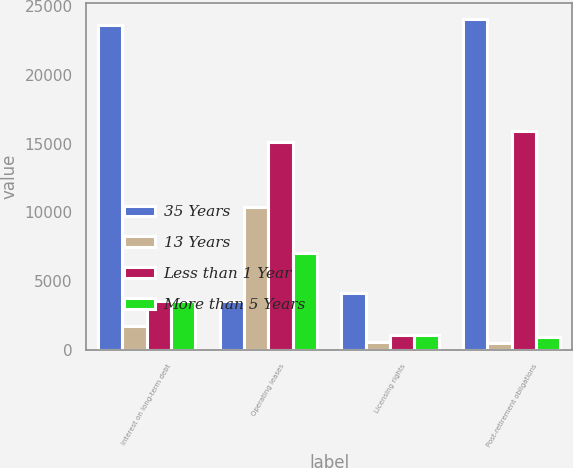Convert chart to OTSL. <chart><loc_0><loc_0><loc_500><loc_500><stacked_bar_chart><ecel><fcel>Interest on long-term debt<fcel>Operating leases<fcel>Licensing rights<fcel>Post-retirement obligations<nl><fcel>35 Years<fcel>23660<fcel>3527<fcel>4125<fcel>24064<nl><fcel>13 Years<fcel>1763<fcel>10388<fcel>550<fcel>504<nl><fcel>Less than 1 Year<fcel>3527<fcel>15142<fcel>1100<fcel>15907<nl><fcel>More than 5 Years<fcel>3527<fcel>7060<fcel>1100<fcel>975<nl></chart> 